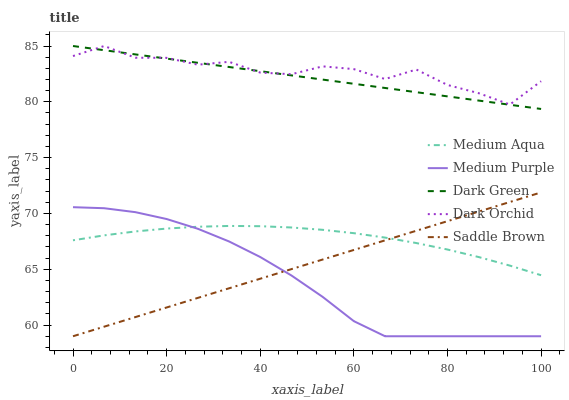Does Medium Purple have the minimum area under the curve?
Answer yes or no. Yes. Does Dark Orchid have the maximum area under the curve?
Answer yes or no. Yes. Does Medium Aqua have the minimum area under the curve?
Answer yes or no. No. Does Medium Aqua have the maximum area under the curve?
Answer yes or no. No. Is Saddle Brown the smoothest?
Answer yes or no. Yes. Is Dark Orchid the roughest?
Answer yes or no. Yes. Is Medium Aqua the smoothest?
Answer yes or no. No. Is Medium Aqua the roughest?
Answer yes or no. No. Does Medium Aqua have the lowest value?
Answer yes or no. No. Does Dark Green have the highest value?
Answer yes or no. Yes. Does Saddle Brown have the highest value?
Answer yes or no. No. Is Medium Aqua less than Dark Orchid?
Answer yes or no. Yes. Is Dark Orchid greater than Medium Purple?
Answer yes or no. Yes. Does Dark Green intersect Dark Orchid?
Answer yes or no. Yes. Is Dark Green less than Dark Orchid?
Answer yes or no. No. Is Dark Green greater than Dark Orchid?
Answer yes or no. No. Does Medium Aqua intersect Dark Orchid?
Answer yes or no. No. 